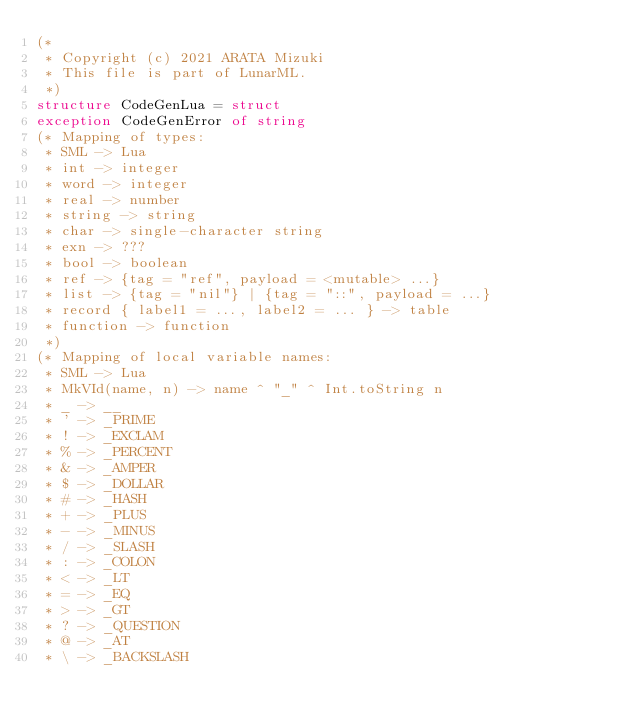<code> <loc_0><loc_0><loc_500><loc_500><_SML_>(*
 * Copyright (c) 2021 ARATA Mizuki
 * This file is part of LunarML.
 *)
structure CodeGenLua = struct
exception CodeGenError of string
(* Mapping of types:
 * SML -> Lua
 * int -> integer
 * word -> integer
 * real -> number
 * string -> string
 * char -> single-character string
 * exn -> ???
 * bool -> boolean
 * ref -> {tag = "ref", payload = <mutable> ...}
 * list -> {tag = "nil"} | {tag = "::", payload = ...}
 * record { label1 = ..., label2 = ... } -> table
 * function -> function
 *)
(* Mapping of local variable names:
 * SML -> Lua
 * MkVId(name, n) -> name ^ "_" ^ Int.toString n
 * _ -> __
 * ' -> _PRIME
 * ! -> _EXCLAM
 * % -> _PERCENT
 * & -> _AMPER
 * $ -> _DOLLAR
 * # -> _HASH
 * + -> _PLUS
 * - -> _MINUS
 * / -> _SLASH
 * : -> _COLON
 * < -> _LT
 * = -> _EQ
 * > -> _GT
 * ? -> _QUESTION
 * @ -> _AT
 * \ -> _BACKSLASH</code> 